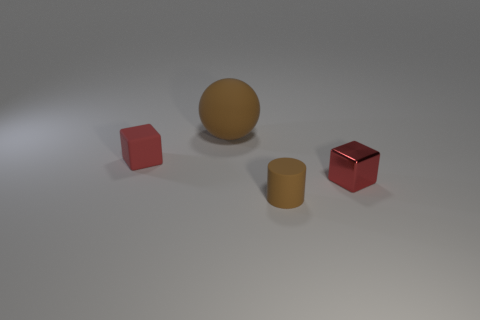Which of the objects in this image reflects light the most, and what does that tell us about the surface of that object? The small shiny block reflects light the most, indicating it has a glossy surface. Glossy surfaces are smooth and polished, allowing light to bounce off in a specular manner, which results in a visible reflection. 